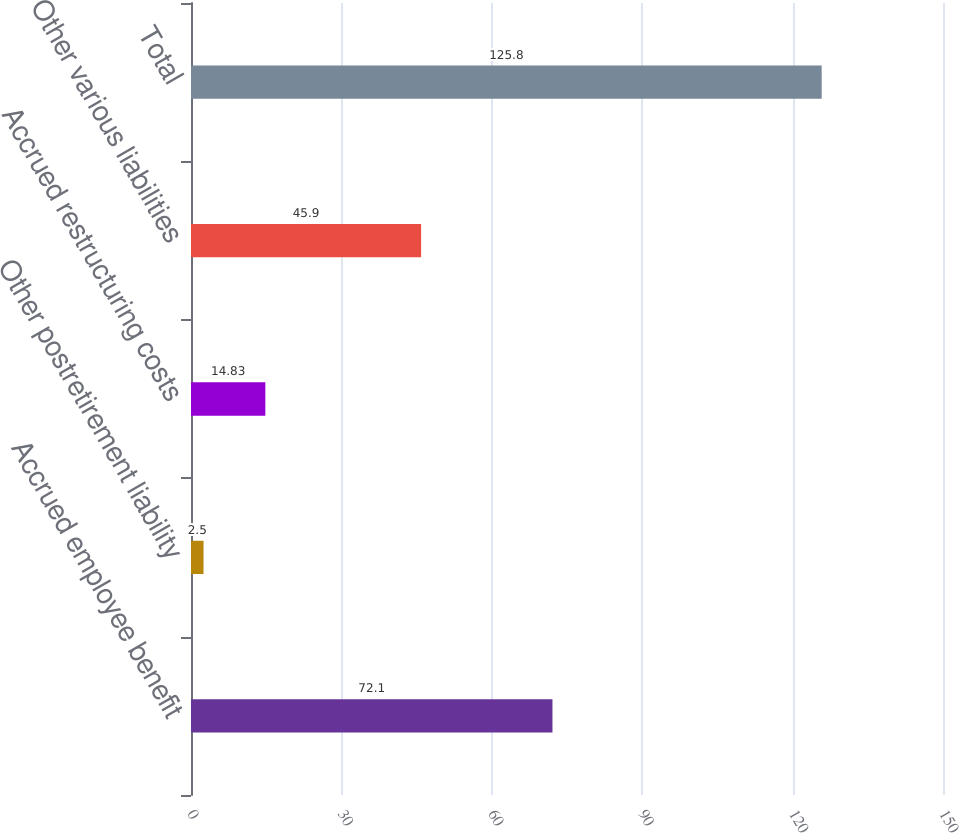<chart> <loc_0><loc_0><loc_500><loc_500><bar_chart><fcel>Accrued employee benefit<fcel>Other postretirement liability<fcel>Accrued restructuring costs<fcel>Other various liabilities<fcel>Total<nl><fcel>72.1<fcel>2.5<fcel>14.83<fcel>45.9<fcel>125.8<nl></chart> 